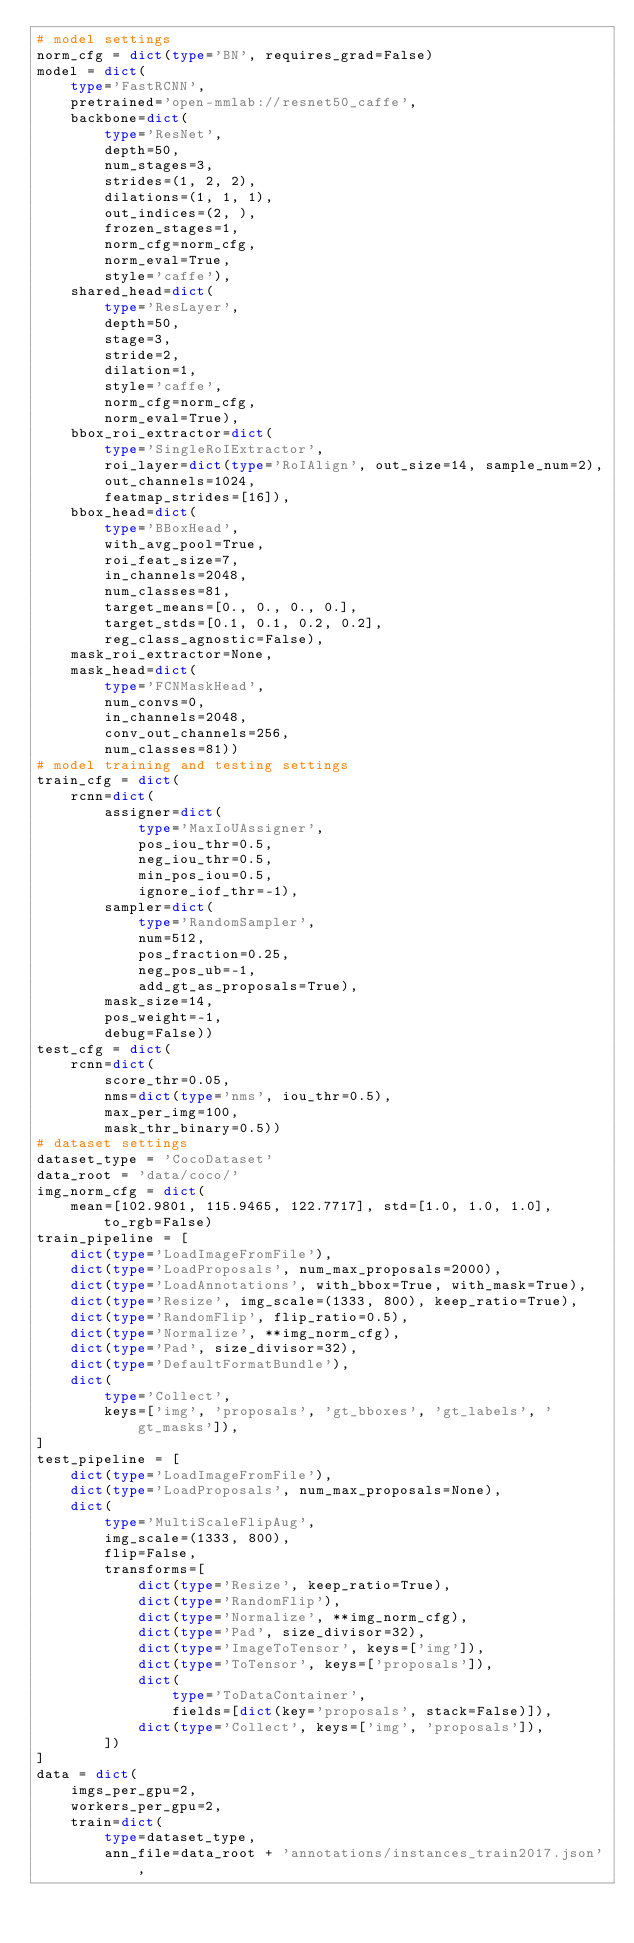Convert code to text. <code><loc_0><loc_0><loc_500><loc_500><_Python_># model settings
norm_cfg = dict(type='BN', requires_grad=False)
model = dict(
    type='FastRCNN',
    pretrained='open-mmlab://resnet50_caffe',
    backbone=dict(
        type='ResNet',
        depth=50,
        num_stages=3,
        strides=(1, 2, 2),
        dilations=(1, 1, 1),
        out_indices=(2, ),
        frozen_stages=1,
        norm_cfg=norm_cfg,
        norm_eval=True,
        style='caffe'),
    shared_head=dict(
        type='ResLayer',
        depth=50,
        stage=3,
        stride=2,
        dilation=1,
        style='caffe',
        norm_cfg=norm_cfg,
        norm_eval=True),
    bbox_roi_extractor=dict(
        type='SingleRoIExtractor',
        roi_layer=dict(type='RoIAlign', out_size=14, sample_num=2),
        out_channels=1024,
        featmap_strides=[16]),
    bbox_head=dict(
        type='BBoxHead',
        with_avg_pool=True,
        roi_feat_size=7,
        in_channels=2048,
        num_classes=81,
        target_means=[0., 0., 0., 0.],
        target_stds=[0.1, 0.1, 0.2, 0.2],
        reg_class_agnostic=False),
    mask_roi_extractor=None,
    mask_head=dict(
        type='FCNMaskHead',
        num_convs=0,
        in_channels=2048,
        conv_out_channels=256,
        num_classes=81))
# model training and testing settings
train_cfg = dict(
    rcnn=dict(
        assigner=dict(
            type='MaxIoUAssigner',
            pos_iou_thr=0.5,
            neg_iou_thr=0.5,
            min_pos_iou=0.5,
            ignore_iof_thr=-1),
        sampler=dict(
            type='RandomSampler',
            num=512,
            pos_fraction=0.25,
            neg_pos_ub=-1,
            add_gt_as_proposals=True),
        mask_size=14,
        pos_weight=-1,
        debug=False))
test_cfg = dict(
    rcnn=dict(
        score_thr=0.05,
        nms=dict(type='nms', iou_thr=0.5),
        max_per_img=100,
        mask_thr_binary=0.5))
# dataset settings
dataset_type = 'CocoDataset'
data_root = 'data/coco/'
img_norm_cfg = dict(
    mean=[102.9801, 115.9465, 122.7717], std=[1.0, 1.0, 1.0], to_rgb=False)
train_pipeline = [
    dict(type='LoadImageFromFile'),
    dict(type='LoadProposals', num_max_proposals=2000),
    dict(type='LoadAnnotations', with_bbox=True, with_mask=True),
    dict(type='Resize', img_scale=(1333, 800), keep_ratio=True),
    dict(type='RandomFlip', flip_ratio=0.5),
    dict(type='Normalize', **img_norm_cfg),
    dict(type='Pad', size_divisor=32),
    dict(type='DefaultFormatBundle'),
    dict(
        type='Collect',
        keys=['img', 'proposals', 'gt_bboxes', 'gt_labels', 'gt_masks']),
]
test_pipeline = [
    dict(type='LoadImageFromFile'),
    dict(type='LoadProposals', num_max_proposals=None),
    dict(
        type='MultiScaleFlipAug',
        img_scale=(1333, 800),
        flip=False,
        transforms=[
            dict(type='Resize', keep_ratio=True),
            dict(type='RandomFlip'),
            dict(type='Normalize', **img_norm_cfg),
            dict(type='Pad', size_divisor=32),
            dict(type='ImageToTensor', keys=['img']),
            dict(type='ToTensor', keys=['proposals']),
            dict(
                type='ToDataContainer',
                fields=[dict(key='proposals', stack=False)]),
            dict(type='Collect', keys=['img', 'proposals']),
        ])
]
data = dict(
    imgs_per_gpu=2,
    workers_per_gpu=2,
    train=dict(
        type=dataset_type,
        ann_file=data_root + 'annotations/instances_train2017.json',</code> 